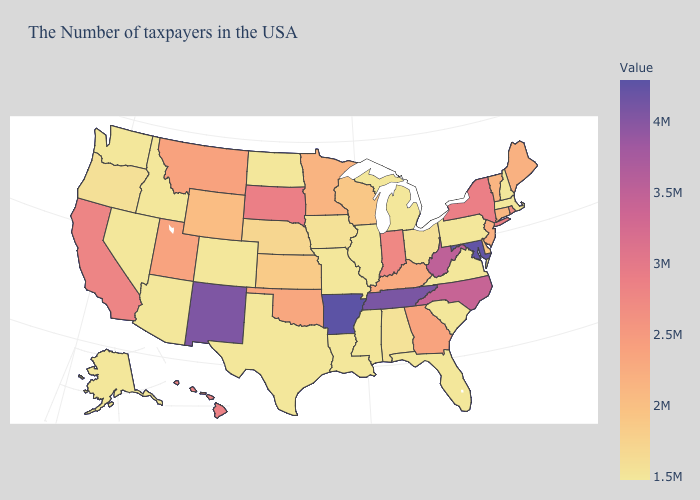Among the states that border New Jersey , which have the highest value?
Give a very brief answer. New York. Which states have the lowest value in the USA?
Be succinct. Massachusetts, New Hampshire, Pennsylvania, Virginia, South Carolina, Florida, Michigan, Illinois, Mississippi, Louisiana, Missouri, Texas, North Dakota, Colorado, Arizona, Idaho, Nevada, Washington, Alaska. Does Mississippi have the lowest value in the South?
Keep it brief. Yes. Which states have the lowest value in the USA?
Write a very short answer. Massachusetts, New Hampshire, Pennsylvania, Virginia, South Carolina, Florida, Michigan, Illinois, Mississippi, Louisiana, Missouri, Texas, North Dakota, Colorado, Arizona, Idaho, Nevada, Washington, Alaska. 